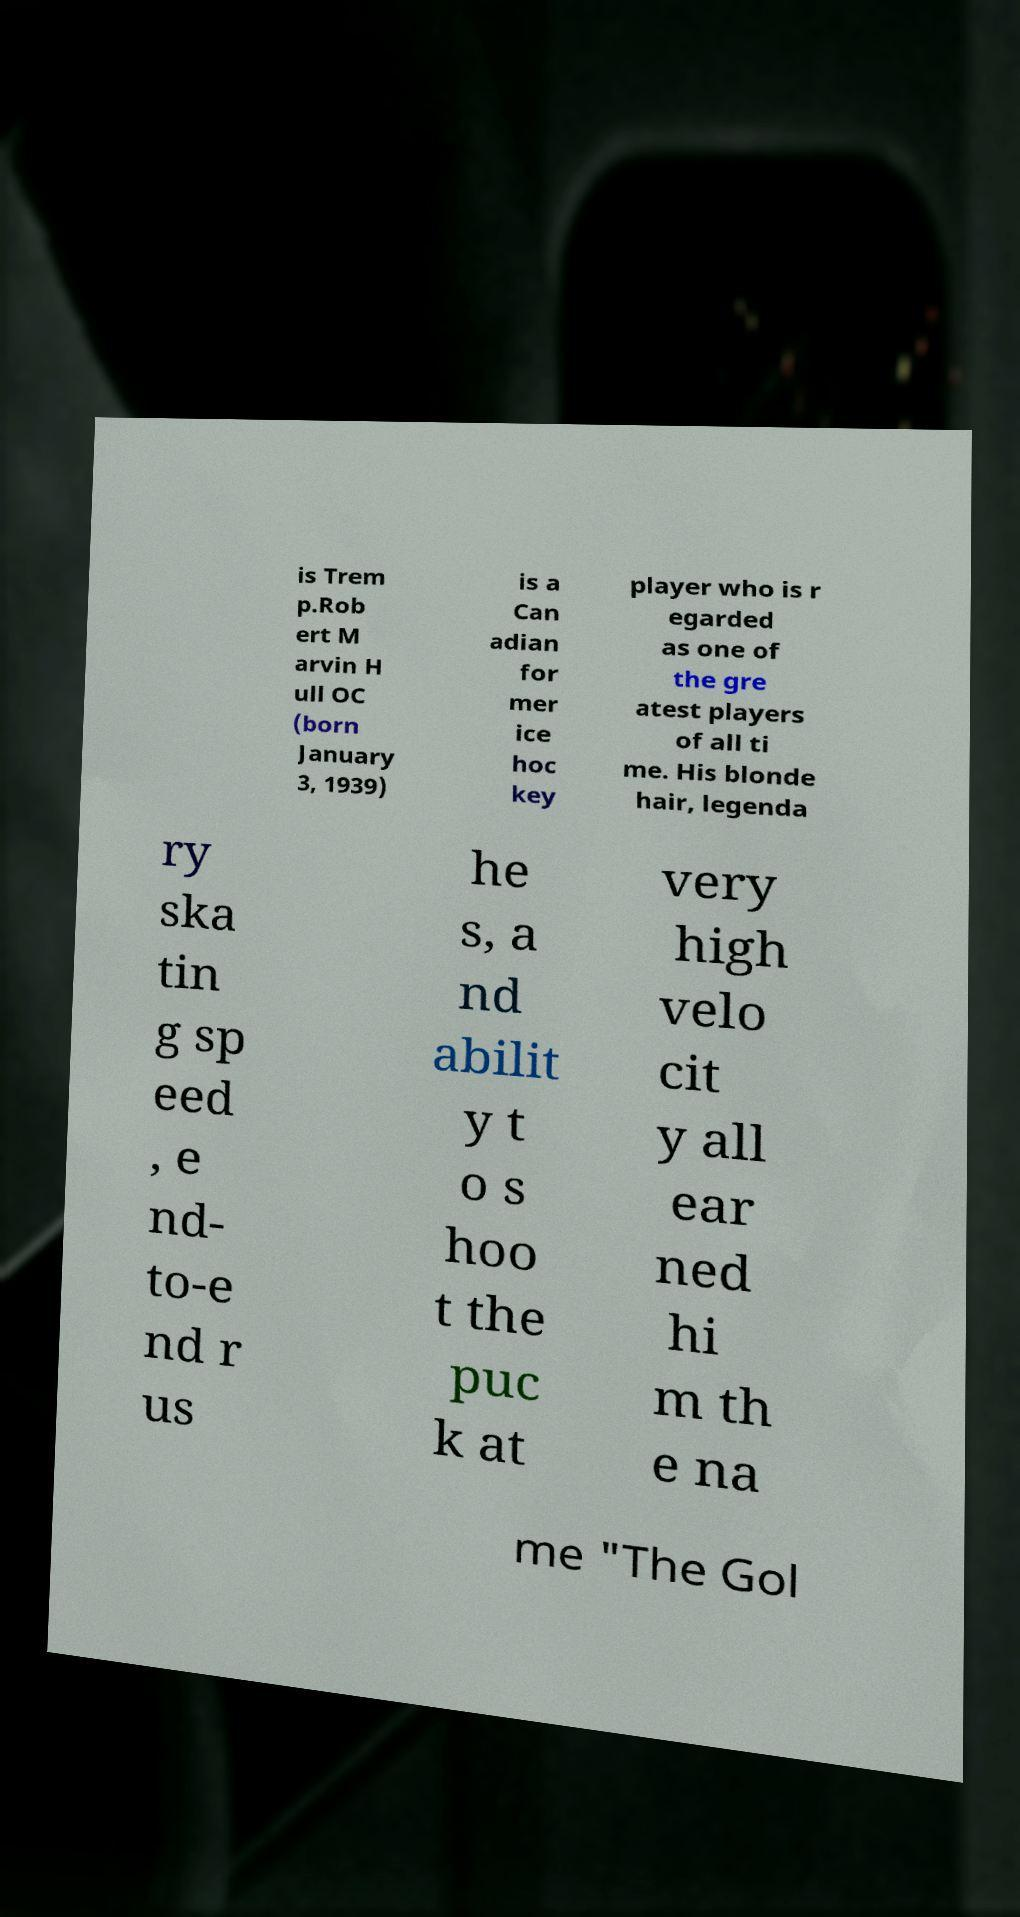Can you read and provide the text displayed in the image?This photo seems to have some interesting text. Can you extract and type it out for me? is Trem p.Rob ert M arvin H ull OC (born January 3, 1939) is a Can adian for mer ice hoc key player who is r egarded as one of the gre atest players of all ti me. His blonde hair, legenda ry ska tin g sp eed , e nd- to-e nd r us he s, a nd abilit y t o s hoo t the puc k at very high velo cit y all ear ned hi m th e na me "The Gol 